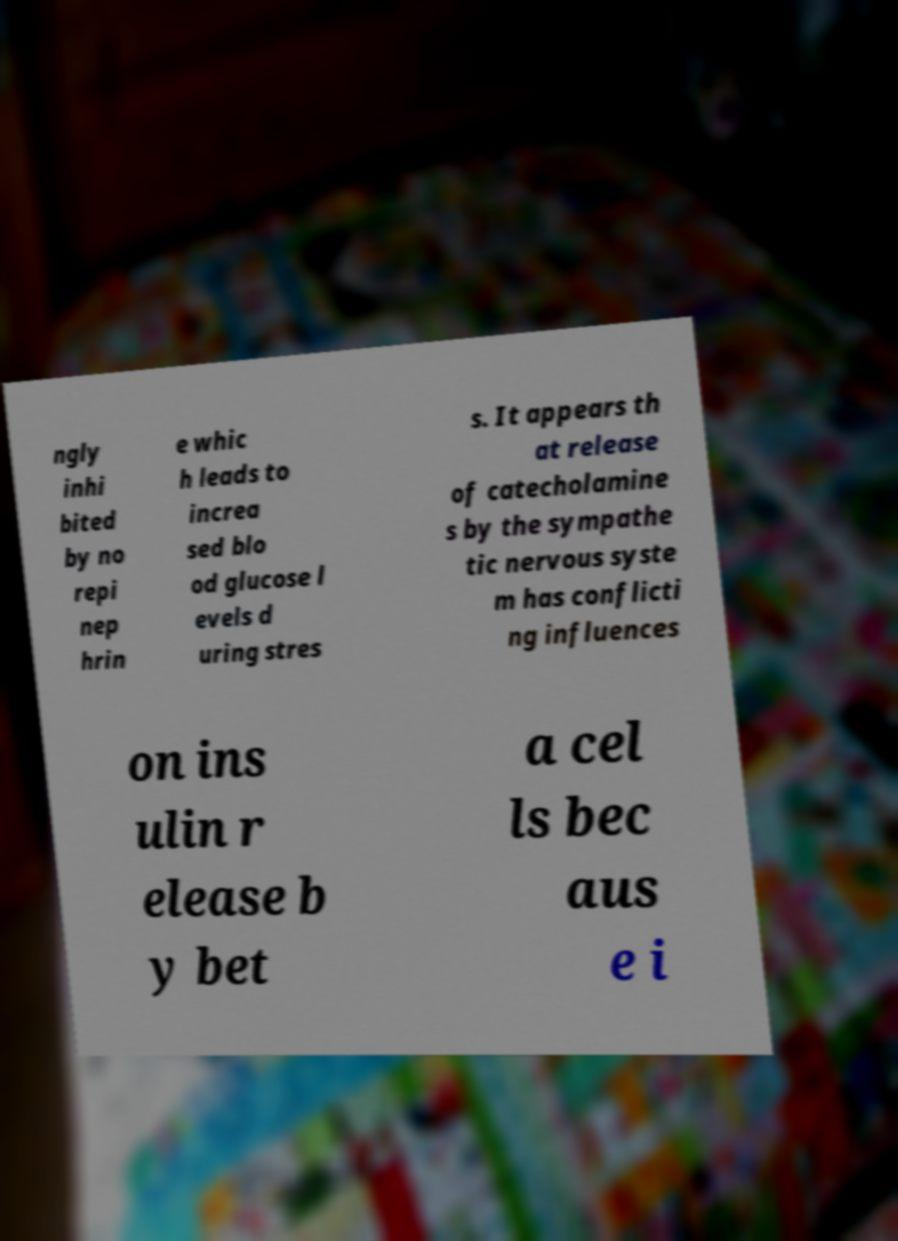Please identify and transcribe the text found in this image. ngly inhi bited by no repi nep hrin e whic h leads to increa sed blo od glucose l evels d uring stres s. It appears th at release of catecholamine s by the sympathe tic nervous syste m has conflicti ng influences on ins ulin r elease b y bet a cel ls bec aus e i 